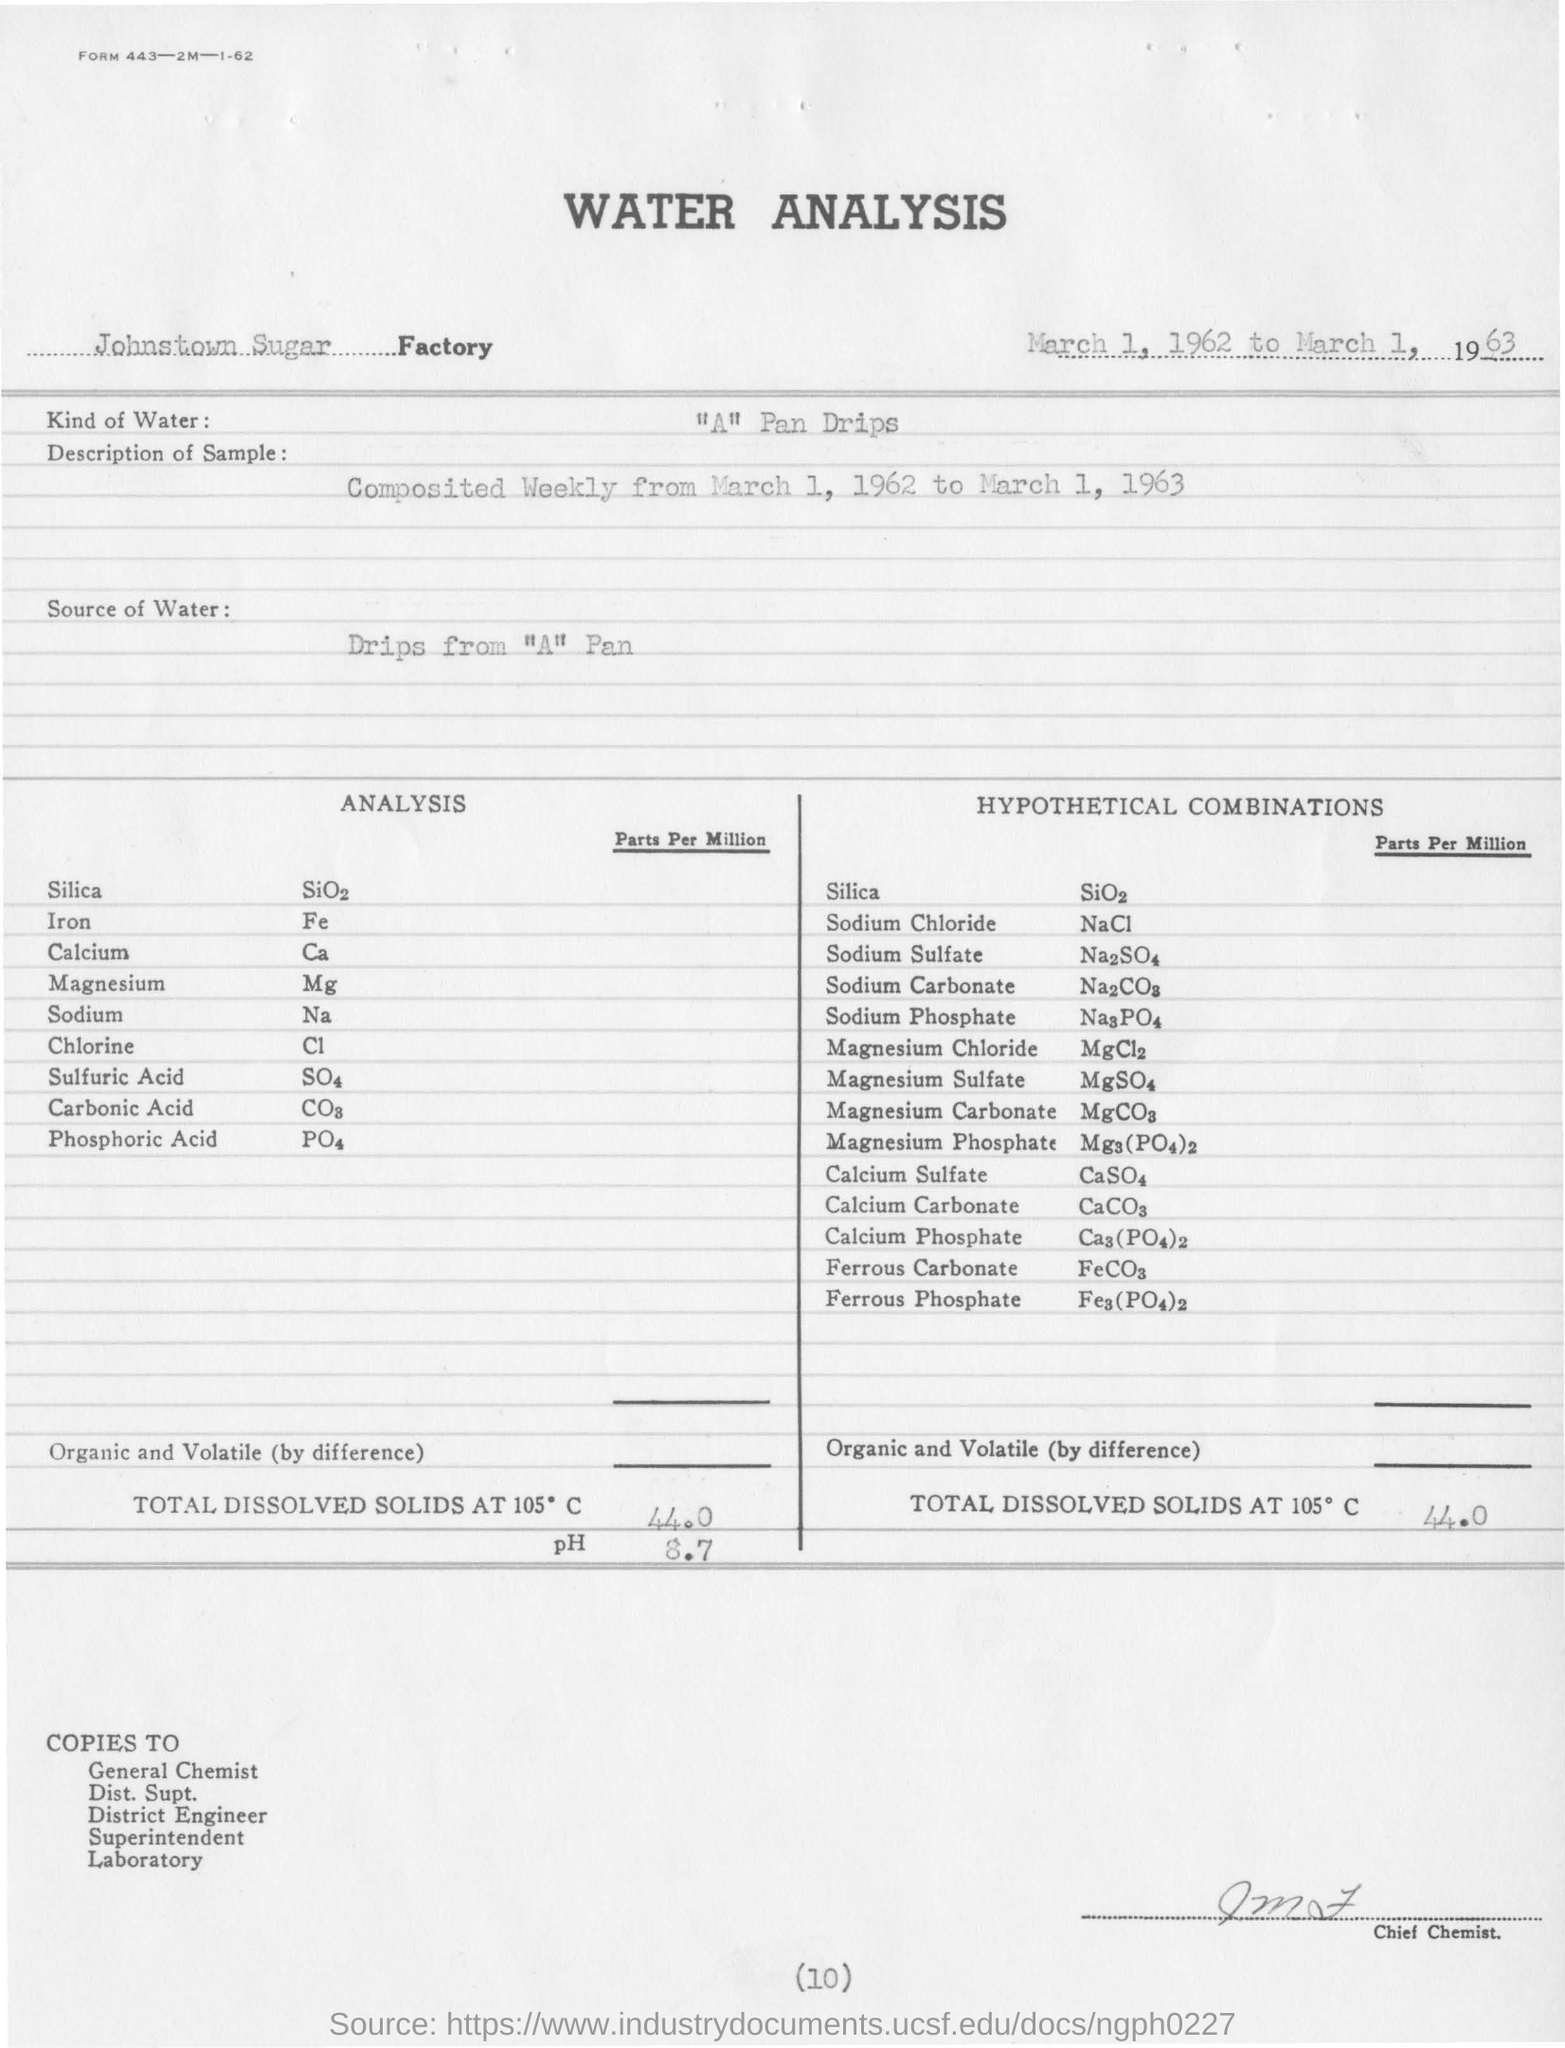What is the name of the factory?
Offer a terse response. Johnstown Sugar. From where the water is taken ?
Give a very brief answer. Drips from "a" pan. What kind of water is used for the analysis?
Offer a very short reply. "A" Pan Drips. What is the amount of total dissolved solids at 105 degrees c ?
Provide a succinct answer. 44.0. What is the value of ph for total dissolved solids at 105 degrees c?
Make the answer very short. 8.7. 